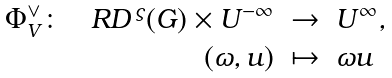Convert formula to latex. <formula><loc_0><loc_0><loc_500><loc_500>\begin{array} { r c l } \Phi _ { V } ^ { \vee } \colon \quad R D ^ { \, \varsigma } ( G ) \times U ^ { - \infty } & \rightarrow & U ^ { \infty } , \\ ( \omega , u ) & \mapsto & \omega u \end{array}</formula> 